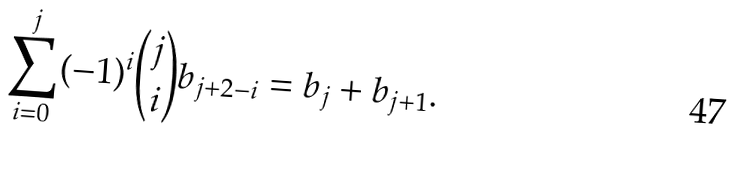<formula> <loc_0><loc_0><loc_500><loc_500>\sum _ { i = 0 } ^ { j } ( - 1 ) ^ { i } \binom { j } { i } b _ { j + 2 - i } = b _ { j } + b _ { j + 1 } .</formula> 